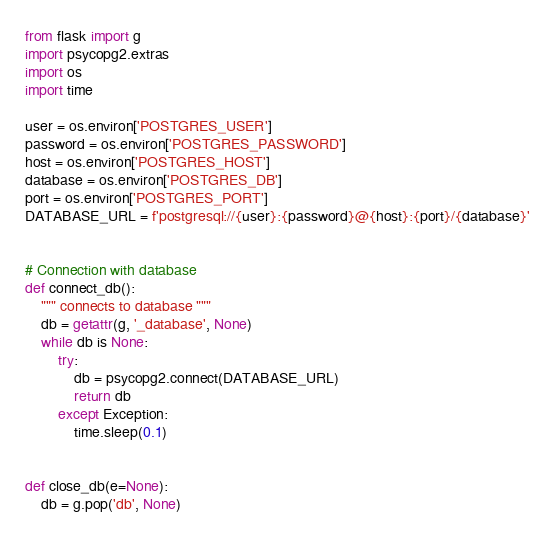Convert code to text. <code><loc_0><loc_0><loc_500><loc_500><_Python_>from flask import g
import psycopg2.extras
import os
import time

user = os.environ['POSTGRES_USER']
password = os.environ['POSTGRES_PASSWORD']
host = os.environ['POSTGRES_HOST']
database = os.environ['POSTGRES_DB']
port = os.environ['POSTGRES_PORT']
DATABASE_URL = f'postgresql://{user}:{password}@{host}:{port}/{database}'


# Connection with database
def connect_db():
    """ connects to database """
    db = getattr(g, '_database', None)
    while db is None:
        try:
            db = psycopg2.connect(DATABASE_URL)
            return db
        except Exception:
            time.sleep(0.1)


def close_db(e=None):
    db = g.pop('db', None)




</code> 